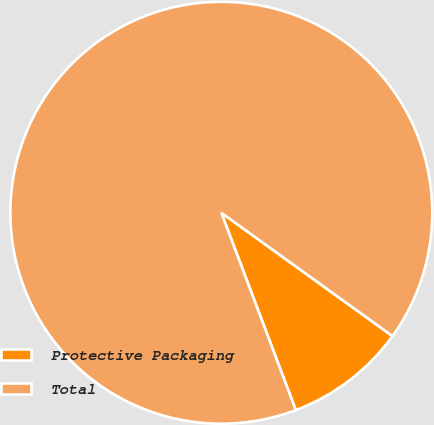Convert chart. <chart><loc_0><loc_0><loc_500><loc_500><pie_chart><fcel>Protective Packaging<fcel>Total<nl><fcel>9.32%<fcel>90.68%<nl></chart> 